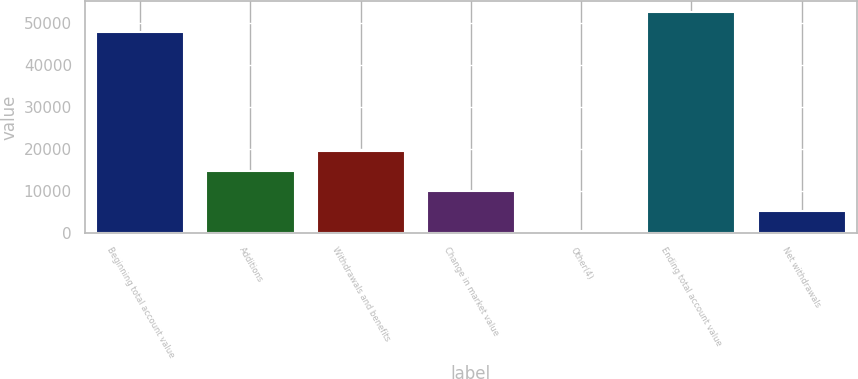<chart> <loc_0><loc_0><loc_500><loc_500><bar_chart><fcel>Beginning total account value<fcel>Additions<fcel>Withdrawals and benefits<fcel>Change in market value<fcel>Other(4)<fcel>Ending total account value<fcel>Net withdrawals<nl><fcel>47680<fcel>14739.7<fcel>19502.6<fcel>9976.8<fcel>451<fcel>52442.9<fcel>5213.9<nl></chart> 